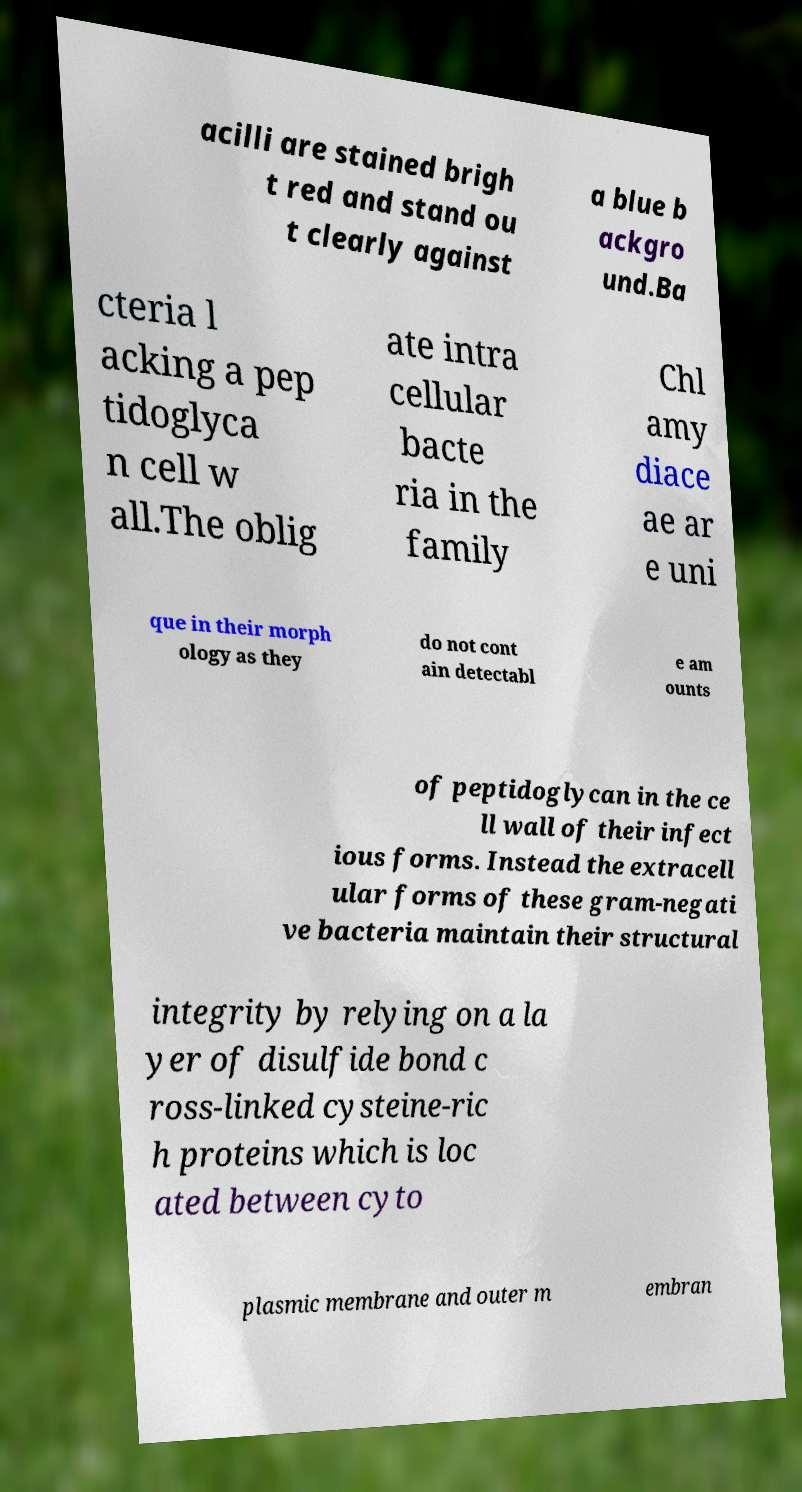Please identify and transcribe the text found in this image. acilli are stained brigh t red and stand ou t clearly against a blue b ackgro und.Ba cteria l acking a pep tidoglyca n cell w all.The oblig ate intra cellular bacte ria in the family Chl amy diace ae ar e uni que in their morph ology as they do not cont ain detectabl e am ounts of peptidoglycan in the ce ll wall of their infect ious forms. Instead the extracell ular forms of these gram-negati ve bacteria maintain their structural integrity by relying on a la yer of disulfide bond c ross-linked cysteine-ric h proteins which is loc ated between cyto plasmic membrane and outer m embran 